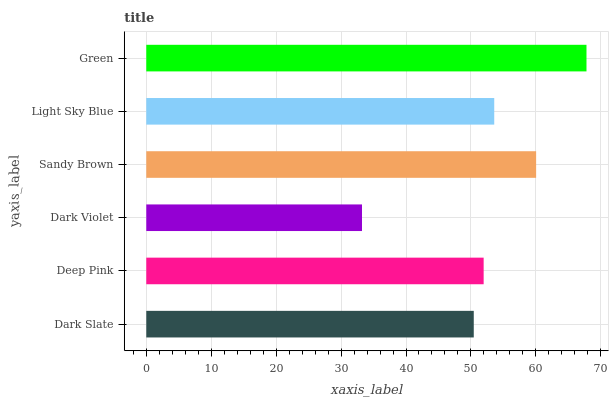Is Dark Violet the minimum?
Answer yes or no. Yes. Is Green the maximum?
Answer yes or no. Yes. Is Deep Pink the minimum?
Answer yes or no. No. Is Deep Pink the maximum?
Answer yes or no. No. Is Deep Pink greater than Dark Slate?
Answer yes or no. Yes. Is Dark Slate less than Deep Pink?
Answer yes or no. Yes. Is Dark Slate greater than Deep Pink?
Answer yes or no. No. Is Deep Pink less than Dark Slate?
Answer yes or no. No. Is Light Sky Blue the high median?
Answer yes or no. Yes. Is Deep Pink the low median?
Answer yes or no. Yes. Is Dark Slate the high median?
Answer yes or no. No. Is Dark Slate the low median?
Answer yes or no. No. 